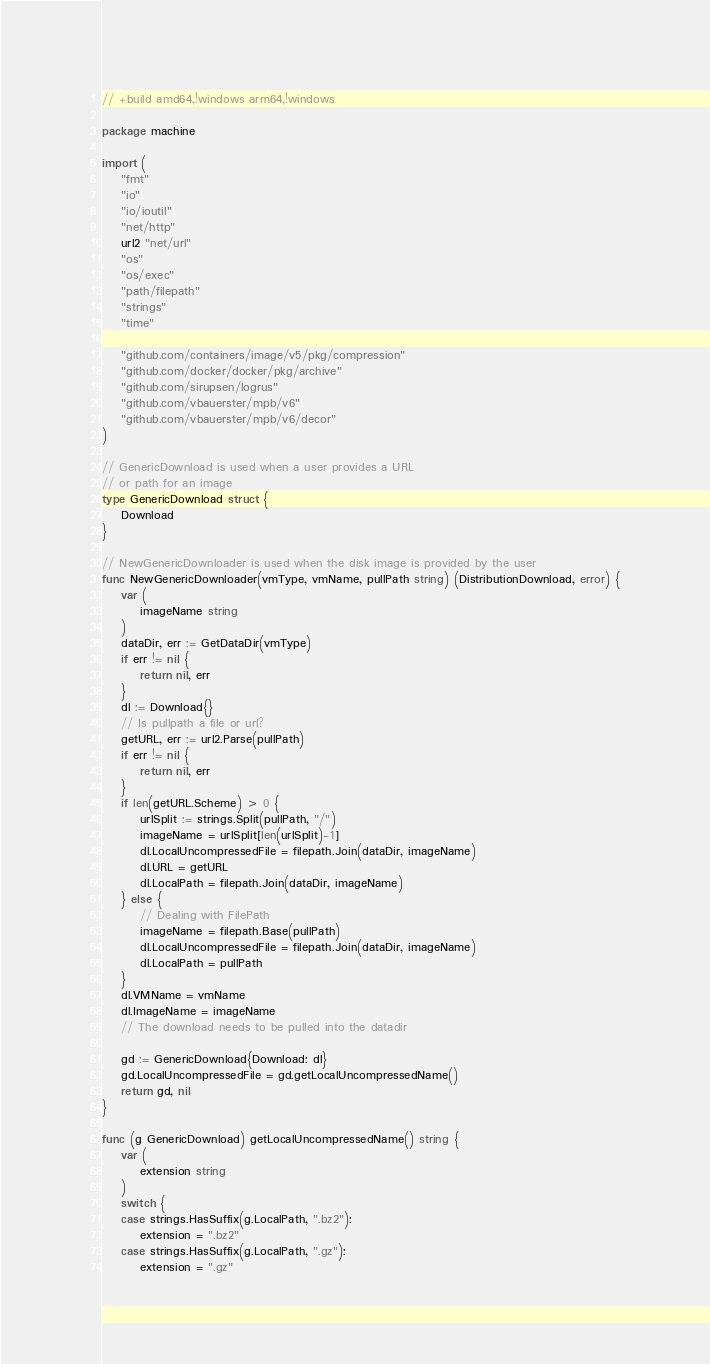<code> <loc_0><loc_0><loc_500><loc_500><_Go_>// +build amd64,!windows arm64,!windows

package machine

import (
	"fmt"
	"io"
	"io/ioutil"
	"net/http"
	url2 "net/url"
	"os"
	"os/exec"
	"path/filepath"
	"strings"
	"time"

	"github.com/containers/image/v5/pkg/compression"
	"github.com/docker/docker/pkg/archive"
	"github.com/sirupsen/logrus"
	"github.com/vbauerster/mpb/v6"
	"github.com/vbauerster/mpb/v6/decor"
)

// GenericDownload is used when a user provides a URL
// or path for an image
type GenericDownload struct {
	Download
}

// NewGenericDownloader is used when the disk image is provided by the user
func NewGenericDownloader(vmType, vmName, pullPath string) (DistributionDownload, error) {
	var (
		imageName string
	)
	dataDir, err := GetDataDir(vmType)
	if err != nil {
		return nil, err
	}
	dl := Download{}
	// Is pullpath a file or url?
	getURL, err := url2.Parse(pullPath)
	if err != nil {
		return nil, err
	}
	if len(getURL.Scheme) > 0 {
		urlSplit := strings.Split(pullPath, "/")
		imageName = urlSplit[len(urlSplit)-1]
		dl.LocalUncompressedFile = filepath.Join(dataDir, imageName)
		dl.URL = getURL
		dl.LocalPath = filepath.Join(dataDir, imageName)
	} else {
		// Dealing with FilePath
		imageName = filepath.Base(pullPath)
		dl.LocalUncompressedFile = filepath.Join(dataDir, imageName)
		dl.LocalPath = pullPath
	}
	dl.VMName = vmName
	dl.ImageName = imageName
	// The download needs to be pulled into the datadir

	gd := GenericDownload{Download: dl}
	gd.LocalUncompressedFile = gd.getLocalUncompressedName()
	return gd, nil
}

func (g GenericDownload) getLocalUncompressedName() string {
	var (
		extension string
	)
	switch {
	case strings.HasSuffix(g.LocalPath, ".bz2"):
		extension = ".bz2"
	case strings.HasSuffix(g.LocalPath, ".gz"):
		extension = ".gz"</code> 